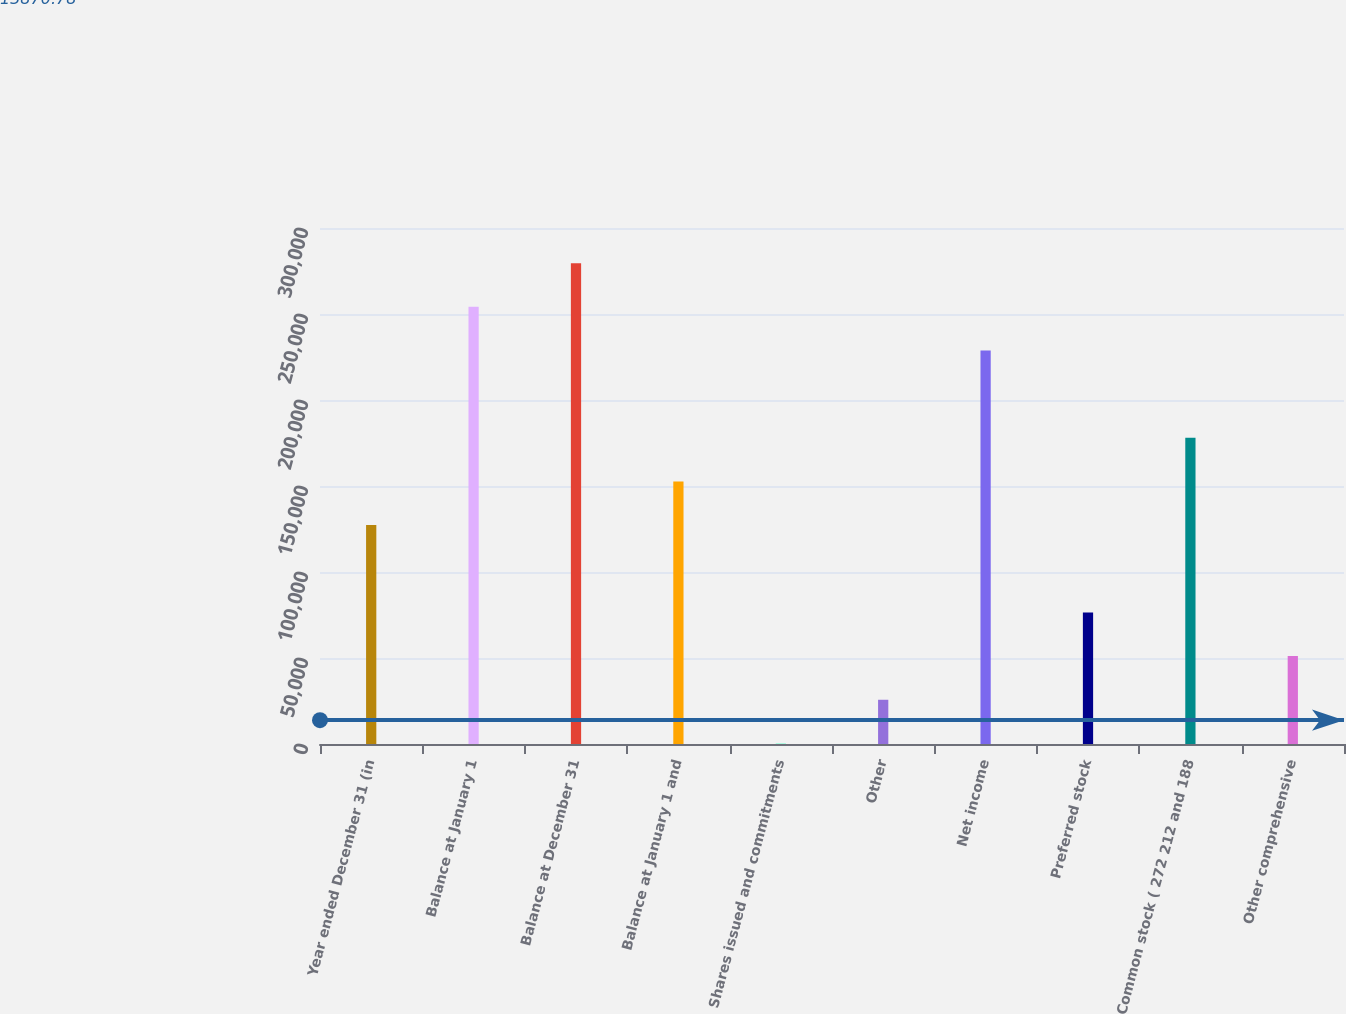Convert chart to OTSL. <chart><loc_0><loc_0><loc_500><loc_500><bar_chart><fcel>Year ended December 31 (in<fcel>Balance at January 1<fcel>Balance at December 31<fcel>Balance at January 1 and<fcel>Shares issued and commitments<fcel>Other<fcel>Net income<fcel>Preferred stock<fcel>Common stock ( 272 212 and 188<fcel>Other comprehensive<nl><fcel>127262<fcel>254190<fcel>279576<fcel>152648<fcel>334<fcel>25719.6<fcel>228804<fcel>76490.8<fcel>178033<fcel>51105.2<nl></chart> 